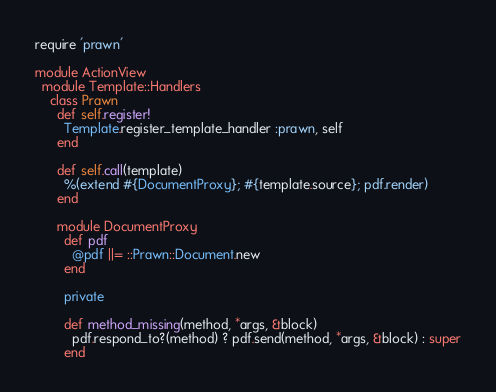<code> <loc_0><loc_0><loc_500><loc_500><_Ruby_>require 'prawn'

module ActionView
  module Template::Handlers
    class Prawn
      def self.register!
        Template.register_template_handler :prawn, self
      end

      def self.call(template)
        %(extend #{DocumentProxy}; #{template.source}; pdf.render)
      end

      module DocumentProxy
        def pdf
          @pdf ||= ::Prawn::Document.new
        end

        private

        def method_missing(method, *args, &block)
          pdf.respond_to?(method) ? pdf.send(method, *args, &block) : super
        end</code> 